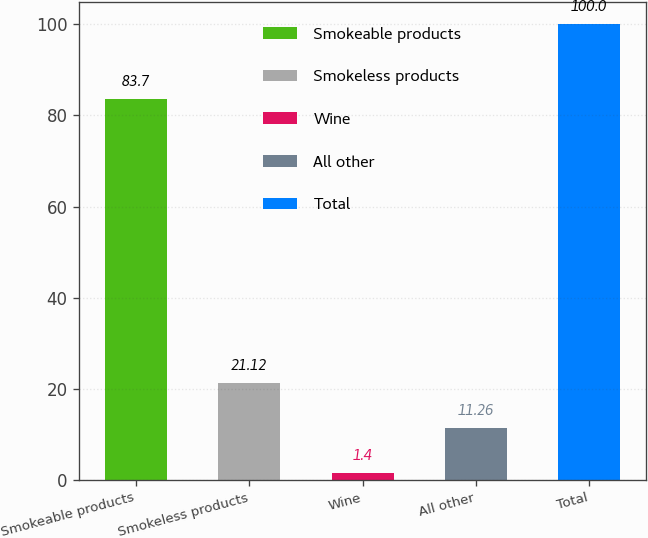<chart> <loc_0><loc_0><loc_500><loc_500><bar_chart><fcel>Smokeable products<fcel>Smokeless products<fcel>Wine<fcel>All other<fcel>Total<nl><fcel>83.7<fcel>21.12<fcel>1.4<fcel>11.26<fcel>100<nl></chart> 